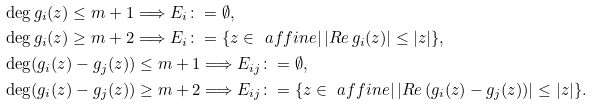Convert formula to latex. <formula><loc_0><loc_0><loc_500><loc_500>& \deg g _ { i } ( z ) \leq m + 1 \Longrightarrow E _ { i } \colon = \emptyset , \\ & \deg g _ { i } ( z ) \geq m + 2 \Longrightarrow E _ { i } \colon = \{ z \in \ a f f i n e | \, | R e \, g _ { i } ( z ) | \leq | z | \} , \\ & \deg ( g _ { i } ( z ) - g _ { j } ( z ) ) \leq m + 1 \Longrightarrow E _ { i j } \colon = \emptyset , \\ & \deg ( g _ { i } ( z ) - g _ { j } ( z ) ) \geq m + 2 \Longrightarrow E _ { i j } \colon = \{ z \in \ a f f i n e | \, | R e \, ( g _ { i } ( z ) - g _ { j } ( z ) ) | \leq | z | \} .</formula> 